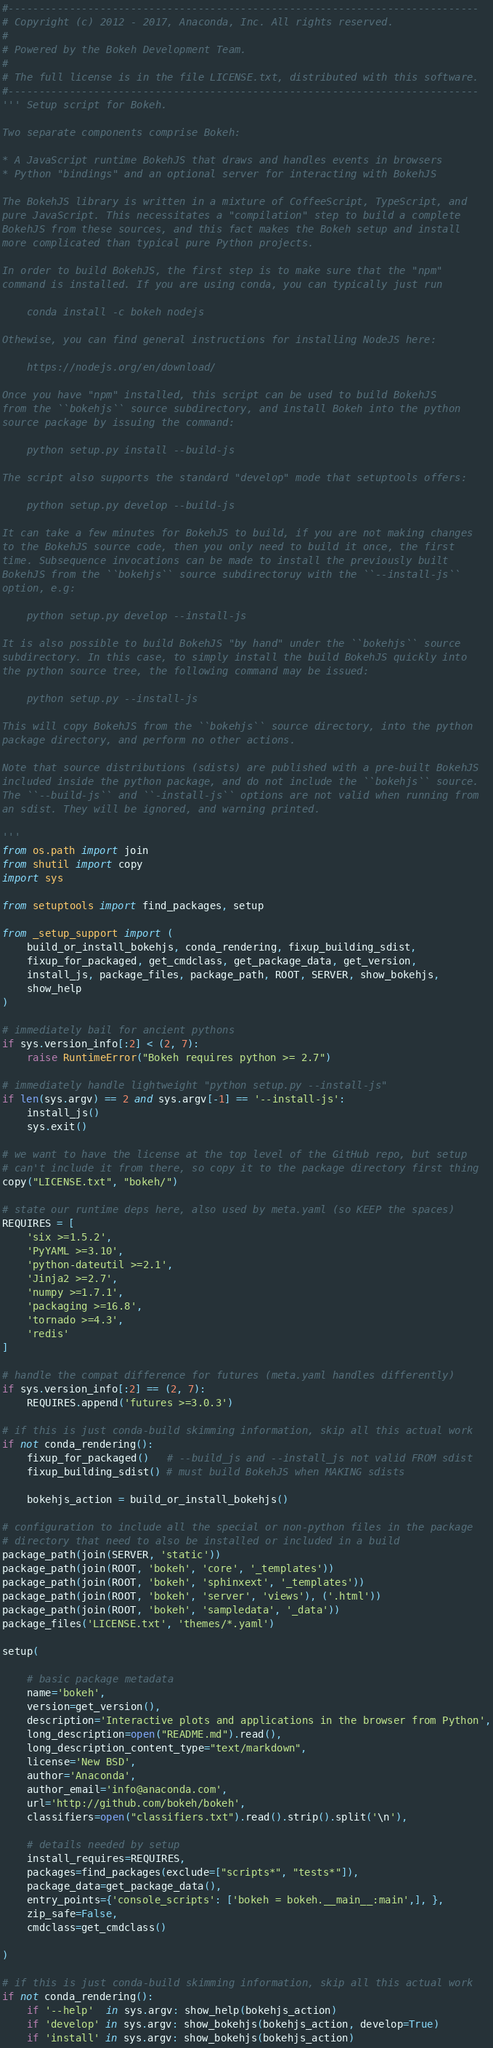<code> <loc_0><loc_0><loc_500><loc_500><_Python_>#-----------------------------------------------------------------------------
# Copyright (c) 2012 - 2017, Anaconda, Inc. All rights reserved.
#
# Powered by the Bokeh Development Team.
#
# The full license is in the file LICENSE.txt, distributed with this software.
#-----------------------------------------------------------------------------
''' Setup script for Bokeh.

Two separate components comprise Bokeh:

* A JavaScript runtime BokehJS that draws and handles events in browsers
* Python "bindings" and an optional server for interacting with BokehJS

The BokehJS library is written in a mixture of CoffeeScript, TypeScript, and
pure JavaScript. This necessitates a "compilation" step to build a complete
BokehJS from these sources, and this fact makes the Bokeh setup and install
more complicated than typical pure Python projects.

In order to build BokehJS, the first step is to make sure that the "npm"
command is installed. If you are using conda, you can typically just run

    conda install -c bokeh nodejs

Othewise, you can find general instructions for installing NodeJS here:

    https://nodejs.org/en/download/

Once you have "npm" installed, this script can be used to build BokehJS
from the ``bokehjs`` source subdirectory, and install Bokeh into the python
source package by issuing the command:

    python setup.py install --build-js

The script also supports the standard "develop" mode that setuptools offers:

    python setup.py develop --build-js

It can take a few minutes for BokehJS to build, if you are not making changes
to the BokehJS source code, then you only need to build it once, the first
time. Subsequence invocations can be made to install the previously built
BokehJS from the ``bokehjs`` source subdirectoruy with the ``--install-js``
option, e.g:

    python setup.py develop --install-js

It is also possible to build BokehJS "by hand" under the ``bokehjs`` source
subdirectory. In this case, to simply install the build BokehJS quickly into
the python source tree, the following command may be issued:

    python setup.py --install-js

This will copy BokehJS from the ``bokehjs`` source directory, into the python
package directory, and perform no other actions.

Note that source distributions (sdists) are published with a pre-built BokehJS
included inside the python package, and do not include the ``bokehjs`` source.
The ``--build-js`` and ``-install-js`` options are not valid when running from
an sdist. They will be ignored, and warning printed.

'''
from os.path import join
from shutil import copy
import sys

from setuptools import find_packages, setup

from _setup_support import (
    build_or_install_bokehjs, conda_rendering, fixup_building_sdist,
    fixup_for_packaged, get_cmdclass, get_package_data, get_version,
    install_js, package_files, package_path, ROOT, SERVER, show_bokehjs,
    show_help
)

# immediately bail for ancient pythons
if sys.version_info[:2] < (2, 7):
    raise RuntimeError("Bokeh requires python >= 2.7")

# immediately handle lightweight "python setup.py --install-js"
if len(sys.argv) == 2 and sys.argv[-1] == '--install-js':
    install_js()
    sys.exit()

# we want to have the license at the top level of the GitHub repo, but setup
# can't include it from there, so copy it to the package directory first thing
copy("LICENSE.txt", "bokeh/")

# state our runtime deps here, also used by meta.yaml (so KEEP the spaces)
REQUIRES = [
    'six >=1.5.2',
    'PyYAML >=3.10',
    'python-dateutil >=2.1',
    'Jinja2 >=2.7',
    'numpy >=1.7.1',
    'packaging >=16.8',
    'tornado >=4.3',
    'redis'
]

# handle the compat difference for futures (meta.yaml handles differently)
if sys.version_info[:2] == (2, 7):
    REQUIRES.append('futures >=3.0.3')

# if this is just conda-build skimming information, skip all this actual work
if not conda_rendering():
    fixup_for_packaged()   # --build_js and --install_js not valid FROM sdist
    fixup_building_sdist() # must build BokehJS when MAKING sdists

    bokehjs_action = build_or_install_bokehjs()

# configuration to include all the special or non-python files in the package
# directory that need to also be installed or included in a build
package_path(join(SERVER, 'static'))
package_path(join(ROOT, 'bokeh', 'core', '_templates'))
package_path(join(ROOT, 'bokeh', 'sphinxext', '_templates'))
package_path(join(ROOT, 'bokeh', 'server', 'views'), ('.html'))
package_path(join(ROOT, 'bokeh', 'sampledata', '_data'))
package_files('LICENSE.txt', 'themes/*.yaml')

setup(

    # basic package metadata
    name='bokeh',
    version=get_version(),
    description='Interactive plots and applications in the browser from Python',
    long_description=open("README.md").read(),
    long_description_content_type="text/markdown",
    license='New BSD',
    author='Anaconda',
    author_email='info@anaconda.com',
    url='http://github.com/bokeh/bokeh',
    classifiers=open("classifiers.txt").read().strip().split('\n'),

    # details needed by setup
    install_requires=REQUIRES,
    packages=find_packages(exclude=["scripts*", "tests*"]),
    package_data=get_package_data(),
    entry_points={'console_scripts': ['bokeh = bokeh.__main__:main',], },
    zip_safe=False,
    cmdclass=get_cmdclass()

)

# if this is just conda-build skimming information, skip all this actual work
if not conda_rendering():
    if '--help'  in sys.argv: show_help(bokehjs_action)
    if 'develop' in sys.argv: show_bokehjs(bokehjs_action, develop=True)
    if 'install' in sys.argv: show_bokehjs(bokehjs_action)
</code> 